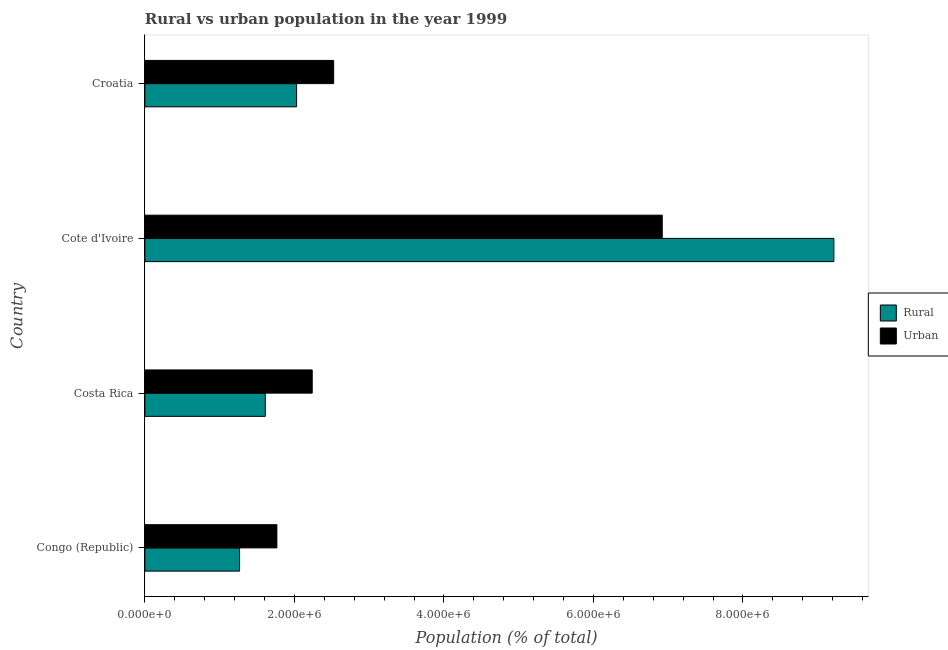How many different coloured bars are there?
Make the answer very short. 2. How many groups of bars are there?
Give a very brief answer. 4. Are the number of bars per tick equal to the number of legend labels?
Give a very brief answer. Yes. How many bars are there on the 2nd tick from the top?
Ensure brevity in your answer.  2. How many bars are there on the 2nd tick from the bottom?
Offer a very short reply. 2. What is the label of the 2nd group of bars from the top?
Offer a terse response. Cote d'Ivoire. In how many cases, is the number of bars for a given country not equal to the number of legend labels?
Your answer should be very brief. 0. What is the urban population density in Costa Rica?
Your answer should be compact. 2.24e+06. Across all countries, what is the maximum urban population density?
Give a very brief answer. 6.92e+06. Across all countries, what is the minimum urban population density?
Your response must be concise. 1.77e+06. In which country was the rural population density maximum?
Keep it short and to the point. Cote d'Ivoire. In which country was the rural population density minimum?
Keep it short and to the point. Congo (Republic). What is the total rural population density in the graph?
Your response must be concise. 1.41e+07. What is the difference between the rural population density in Costa Rica and that in Cote d'Ivoire?
Make the answer very short. -7.61e+06. What is the difference between the rural population density in Cote d'Ivoire and the urban population density in Congo (Republic)?
Offer a very short reply. 7.45e+06. What is the average rural population density per country?
Ensure brevity in your answer.  3.53e+06. What is the difference between the rural population density and urban population density in Congo (Republic)?
Offer a terse response. -4.99e+05. What is the ratio of the rural population density in Congo (Republic) to that in Croatia?
Provide a succinct answer. 0.62. Is the rural population density in Costa Rica less than that in Croatia?
Your response must be concise. Yes. Is the difference between the rural population density in Congo (Republic) and Cote d'Ivoire greater than the difference between the urban population density in Congo (Republic) and Cote d'Ivoire?
Keep it short and to the point. No. What is the difference between the highest and the second highest rural population density?
Give a very brief answer. 7.19e+06. What is the difference between the highest and the lowest urban population density?
Make the answer very short. 5.16e+06. In how many countries, is the rural population density greater than the average rural population density taken over all countries?
Your response must be concise. 1. Is the sum of the urban population density in Congo (Republic) and Cote d'Ivoire greater than the maximum rural population density across all countries?
Offer a terse response. No. What does the 2nd bar from the top in Costa Rica represents?
Provide a short and direct response. Rural. What does the 1st bar from the bottom in Croatia represents?
Keep it short and to the point. Rural. Are all the bars in the graph horizontal?
Your answer should be very brief. Yes. What is the difference between two consecutive major ticks on the X-axis?
Make the answer very short. 2.00e+06. Are the values on the major ticks of X-axis written in scientific E-notation?
Your answer should be very brief. Yes. Does the graph contain any zero values?
Ensure brevity in your answer.  No. Where does the legend appear in the graph?
Offer a very short reply. Center right. How many legend labels are there?
Make the answer very short. 2. How are the legend labels stacked?
Offer a terse response. Vertical. What is the title of the graph?
Give a very brief answer. Rural vs urban population in the year 1999. What is the label or title of the X-axis?
Your answer should be compact. Population (% of total). What is the label or title of the Y-axis?
Ensure brevity in your answer.  Country. What is the Population (% of total) of Rural in Congo (Republic)?
Offer a very short reply. 1.27e+06. What is the Population (% of total) of Urban in Congo (Republic)?
Your response must be concise. 1.77e+06. What is the Population (% of total) of Rural in Costa Rica?
Keep it short and to the point. 1.61e+06. What is the Population (% of total) in Urban in Costa Rica?
Offer a very short reply. 2.24e+06. What is the Population (% of total) in Rural in Cote d'Ivoire?
Offer a terse response. 9.22e+06. What is the Population (% of total) of Urban in Cote d'Ivoire?
Your answer should be very brief. 6.92e+06. What is the Population (% of total) in Rural in Croatia?
Give a very brief answer. 2.03e+06. What is the Population (% of total) in Urban in Croatia?
Your answer should be very brief. 2.53e+06. Across all countries, what is the maximum Population (% of total) in Rural?
Ensure brevity in your answer.  9.22e+06. Across all countries, what is the maximum Population (% of total) in Urban?
Keep it short and to the point. 6.92e+06. Across all countries, what is the minimum Population (% of total) in Rural?
Keep it short and to the point. 1.27e+06. Across all countries, what is the minimum Population (% of total) in Urban?
Make the answer very short. 1.77e+06. What is the total Population (% of total) in Rural in the graph?
Offer a very short reply. 1.41e+07. What is the total Population (% of total) in Urban in the graph?
Your answer should be compact. 1.34e+07. What is the difference between the Population (% of total) in Rural in Congo (Republic) and that in Costa Rica?
Ensure brevity in your answer.  -3.44e+05. What is the difference between the Population (% of total) of Urban in Congo (Republic) and that in Costa Rica?
Your answer should be very brief. -4.73e+05. What is the difference between the Population (% of total) of Rural in Congo (Republic) and that in Cote d'Ivoire?
Your answer should be very brief. -7.95e+06. What is the difference between the Population (% of total) of Urban in Congo (Republic) and that in Cote d'Ivoire?
Give a very brief answer. -5.16e+06. What is the difference between the Population (% of total) of Rural in Congo (Republic) and that in Croatia?
Ensure brevity in your answer.  -7.62e+05. What is the difference between the Population (% of total) in Urban in Congo (Republic) and that in Croatia?
Give a very brief answer. -7.60e+05. What is the difference between the Population (% of total) of Rural in Costa Rica and that in Cote d'Ivoire?
Ensure brevity in your answer.  -7.61e+06. What is the difference between the Population (% of total) in Urban in Costa Rica and that in Cote d'Ivoire?
Ensure brevity in your answer.  -4.68e+06. What is the difference between the Population (% of total) of Rural in Costa Rica and that in Croatia?
Keep it short and to the point. -4.18e+05. What is the difference between the Population (% of total) in Urban in Costa Rica and that in Croatia?
Ensure brevity in your answer.  -2.87e+05. What is the difference between the Population (% of total) in Rural in Cote d'Ivoire and that in Croatia?
Keep it short and to the point. 7.19e+06. What is the difference between the Population (% of total) in Urban in Cote d'Ivoire and that in Croatia?
Provide a short and direct response. 4.40e+06. What is the difference between the Population (% of total) in Rural in Congo (Republic) and the Population (% of total) in Urban in Costa Rica?
Offer a terse response. -9.72e+05. What is the difference between the Population (% of total) of Rural in Congo (Republic) and the Population (% of total) of Urban in Cote d'Ivoire?
Your answer should be very brief. -5.65e+06. What is the difference between the Population (% of total) in Rural in Congo (Republic) and the Population (% of total) in Urban in Croatia?
Provide a succinct answer. -1.26e+06. What is the difference between the Population (% of total) of Rural in Costa Rica and the Population (% of total) of Urban in Cote d'Ivoire?
Your answer should be compact. -5.31e+06. What is the difference between the Population (% of total) of Rural in Costa Rica and the Population (% of total) of Urban in Croatia?
Your answer should be very brief. -9.15e+05. What is the difference between the Population (% of total) in Rural in Cote d'Ivoire and the Population (% of total) in Urban in Croatia?
Give a very brief answer. 6.69e+06. What is the average Population (% of total) in Rural per country?
Offer a very short reply. 3.53e+06. What is the average Population (% of total) of Urban per country?
Offer a terse response. 3.36e+06. What is the difference between the Population (% of total) of Rural and Population (% of total) of Urban in Congo (Republic)?
Offer a terse response. -4.99e+05. What is the difference between the Population (% of total) of Rural and Population (% of total) of Urban in Costa Rica?
Make the answer very short. -6.28e+05. What is the difference between the Population (% of total) of Rural and Population (% of total) of Urban in Cote d'Ivoire?
Give a very brief answer. 2.30e+06. What is the difference between the Population (% of total) of Rural and Population (% of total) of Urban in Croatia?
Ensure brevity in your answer.  -4.96e+05. What is the ratio of the Population (% of total) in Rural in Congo (Republic) to that in Costa Rica?
Your response must be concise. 0.79. What is the ratio of the Population (% of total) in Urban in Congo (Republic) to that in Costa Rica?
Your answer should be very brief. 0.79. What is the ratio of the Population (% of total) of Rural in Congo (Republic) to that in Cote d'Ivoire?
Make the answer very short. 0.14. What is the ratio of the Population (% of total) of Urban in Congo (Republic) to that in Cote d'Ivoire?
Keep it short and to the point. 0.26. What is the ratio of the Population (% of total) of Rural in Congo (Republic) to that in Croatia?
Provide a short and direct response. 0.62. What is the ratio of the Population (% of total) of Urban in Congo (Republic) to that in Croatia?
Your answer should be very brief. 0.7. What is the ratio of the Population (% of total) of Rural in Costa Rica to that in Cote d'Ivoire?
Provide a succinct answer. 0.17. What is the ratio of the Population (% of total) in Urban in Costa Rica to that in Cote d'Ivoire?
Your answer should be compact. 0.32. What is the ratio of the Population (% of total) of Rural in Costa Rica to that in Croatia?
Keep it short and to the point. 0.79. What is the ratio of the Population (% of total) of Urban in Costa Rica to that in Croatia?
Ensure brevity in your answer.  0.89. What is the ratio of the Population (% of total) of Rural in Cote d'Ivoire to that in Croatia?
Ensure brevity in your answer.  4.54. What is the ratio of the Population (% of total) in Urban in Cote d'Ivoire to that in Croatia?
Your response must be concise. 2.74. What is the difference between the highest and the second highest Population (% of total) in Rural?
Provide a succinct answer. 7.19e+06. What is the difference between the highest and the second highest Population (% of total) of Urban?
Keep it short and to the point. 4.40e+06. What is the difference between the highest and the lowest Population (% of total) of Rural?
Offer a terse response. 7.95e+06. What is the difference between the highest and the lowest Population (% of total) in Urban?
Your answer should be very brief. 5.16e+06. 